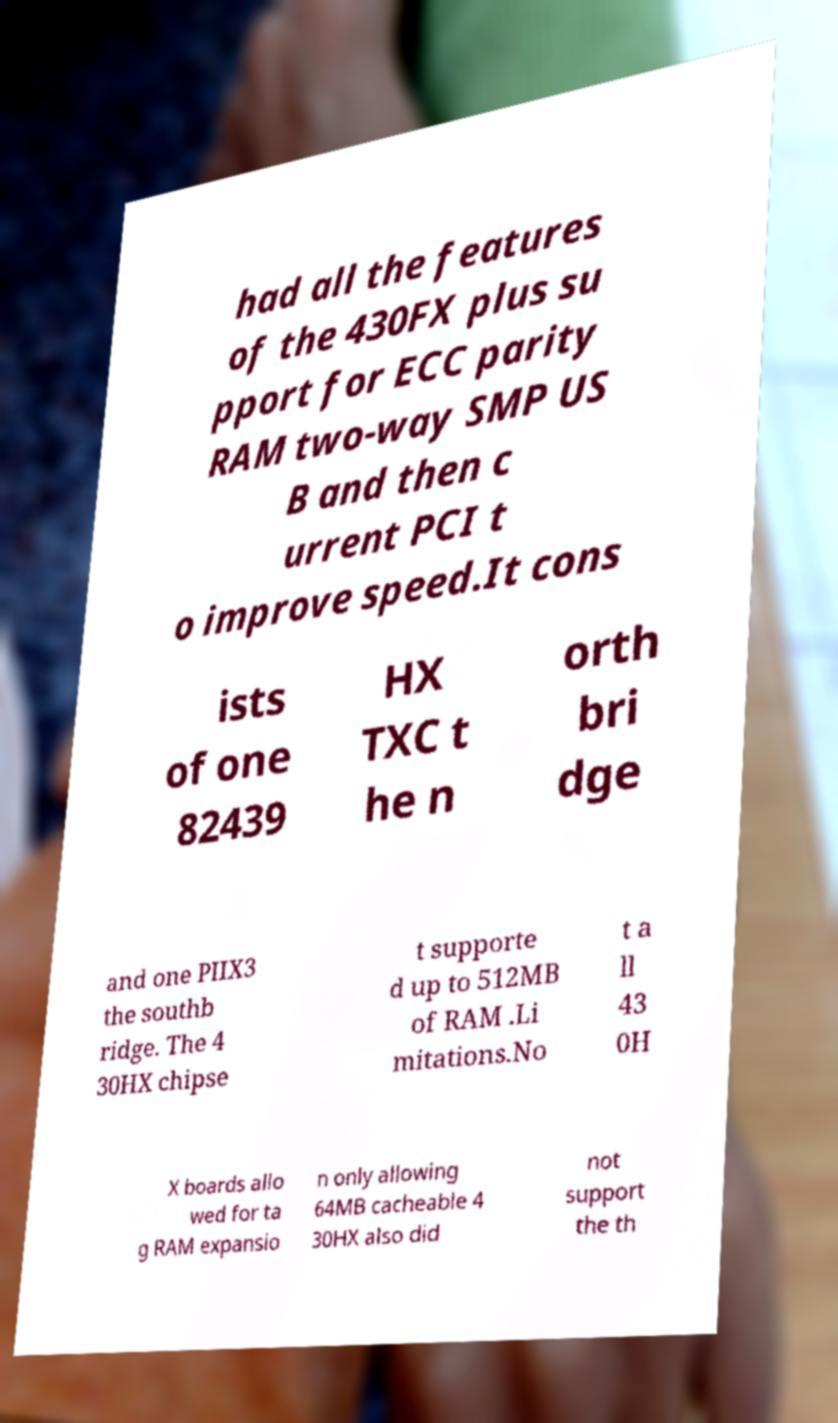Can you read and provide the text displayed in the image?This photo seems to have some interesting text. Can you extract and type it out for me? had all the features of the 430FX plus su pport for ECC parity RAM two-way SMP US B and then c urrent PCI t o improve speed.It cons ists of one 82439 HX TXC t he n orth bri dge and one PIIX3 the southb ridge. The 4 30HX chipse t supporte d up to 512MB of RAM .Li mitations.No t a ll 43 0H X boards allo wed for ta g RAM expansio n only allowing 64MB cacheable 4 30HX also did not support the th 